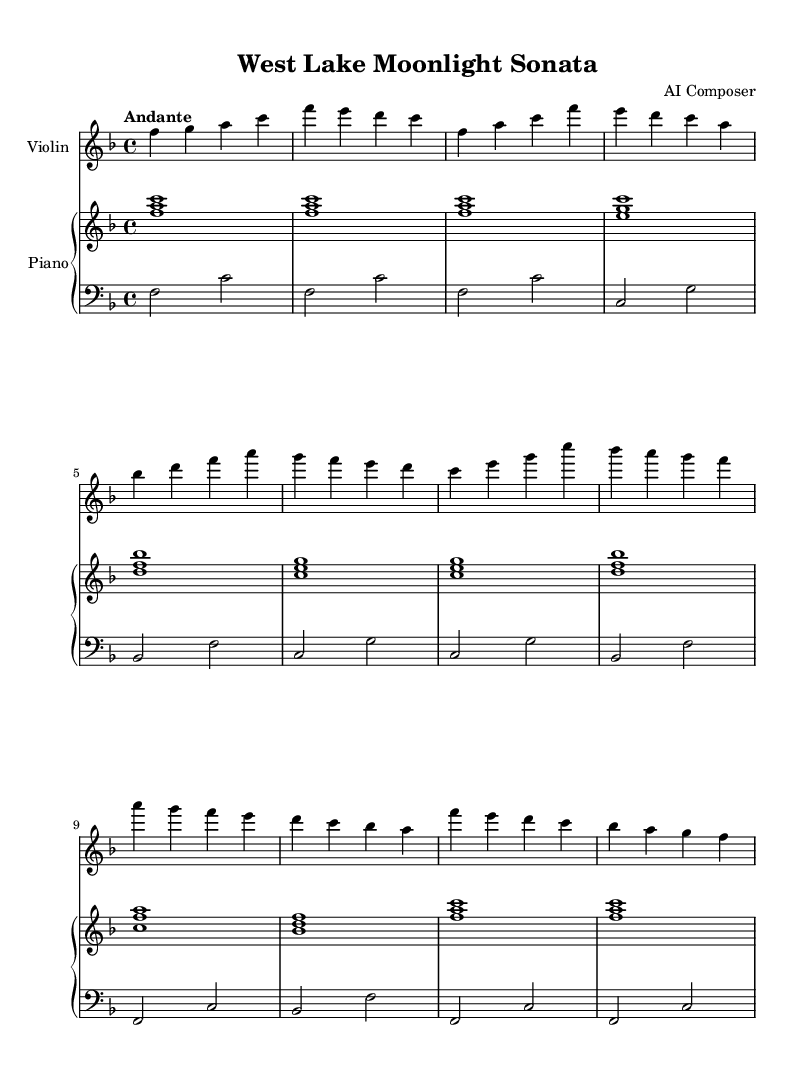What is the key signature of this music? The key signature is F major, which consists of one flat (B flat). This can be identified by looking at the key signature section at the beginning of the staff, where one flat symbol is shown.
Answer: F major What is the time signature of the piece? The time signature is 4/4, indicated at the beginning of the sheet music. This shows that there are four beats in each measure and the quarter note gets one beat.
Answer: 4/4 What tempo is indicated for this piece? The tempo marking is "Andante," which suggests a moderately slow pace. This is specified at the beginning of the score.
Answer: Andante How many themes does the composition present? The score clearly delineates two distinct themes, labeled "Theme A" and "Theme B" within the music. Each theme has its own melodic character and is repeated throughout the piece.
Answer: Two What is the structure of the composition based on the sections labeled? The composition is structured with an introduction, followed by Theme A, Theme B, and a Coda. This organization helps in understanding the overall form of the piece.
Answer: Introduction, Theme A, Theme B, Coda Which instrument is featured in the melody? The violin is the instrument designated for the main melody, as indicated in the score at the top of the violin staff.
Answer: Violin What is the mood conveyed through this composition? The composition conveys a romantic and serene mood, characterized by smooth melodic lines and flowing harmonies, evoking the beauty of landscapes like those found in Hangzhou.
Answer: Romantic and serene 